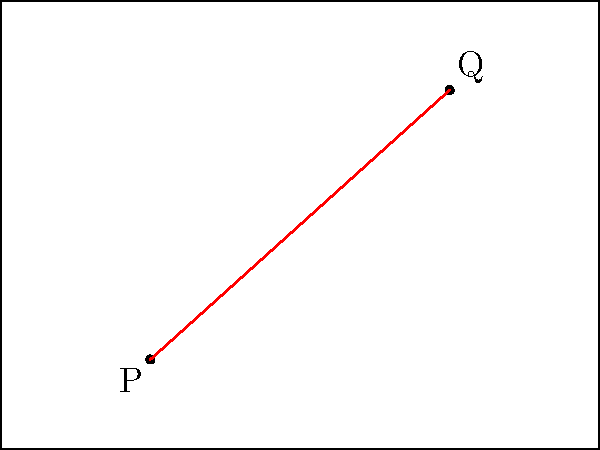In a cricket pitch diagram, two points P(5,3) and Q(15,12) represent the positions of two fielders. Find the equation of the line passing through these two points in slope-intercept form $(y = mx + b)$. To find the equation of the line passing through two points, we'll follow these steps:

1. Calculate the slope (m) using the slope formula:
   $$m = \frac{y_2 - y_1}{x_2 - x_1} = \frac{12 - 3}{15 - 5} = \frac{9}{10} = 0.9$$

2. Use the point-slope form of a line equation with either point. Let's use P(5,3):
   $$y - y_1 = m(x - x_1)$$
   $$y - 3 = 0.9(x - 5)$$

3. Expand the equation:
   $$y - 3 = 0.9x - 4.5$$

4. Rearrange to slope-intercept form $(y = mx + b)$:
   $$y = 0.9x - 4.5 + 3$$
   $$y = 0.9x - 1.5$$

Therefore, the equation of the line in slope-intercept form is $y = 0.9x - 1.5$.
Answer: $y = 0.9x - 1.5$ 